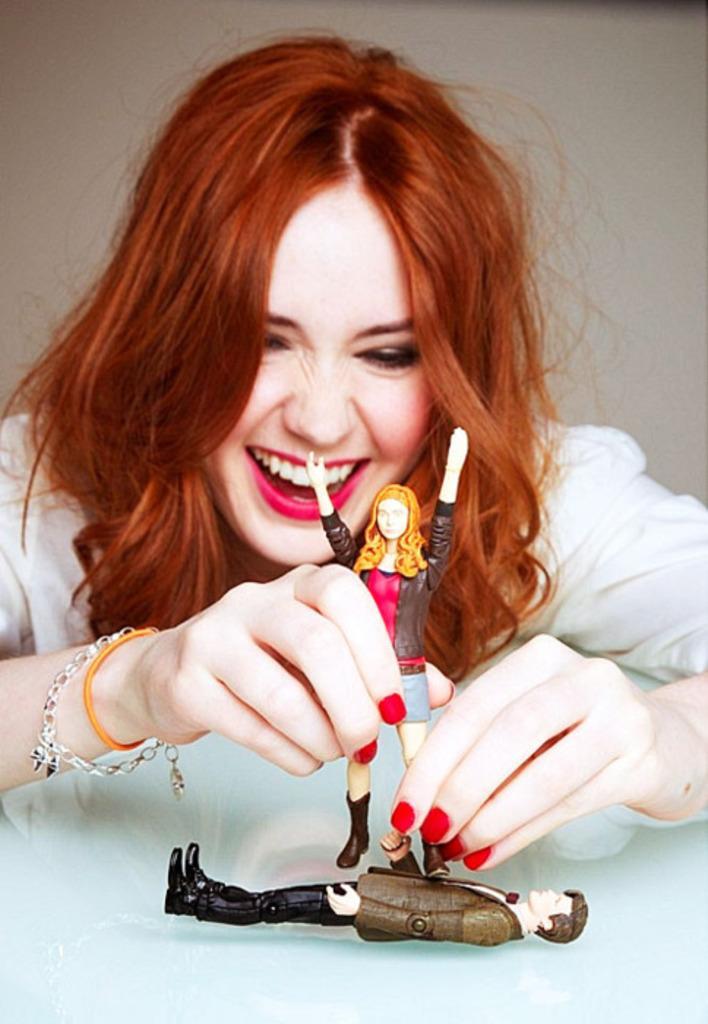Could you give a brief overview of what you see in this image? In this picture we can see a woman smiling and holding a doll with her hands and in front of her we can see a toy on the platform. 